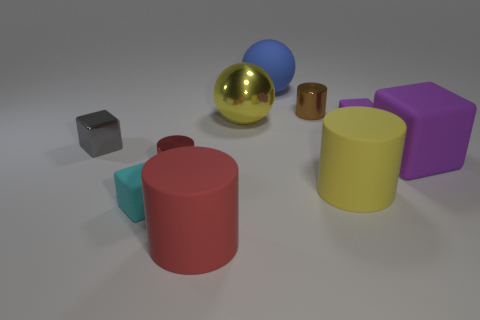Subtract all green cylinders. Subtract all yellow blocks. How many cylinders are left? 4 Subtract all cylinders. How many objects are left? 6 Subtract 0 green cubes. How many objects are left? 10 Subtract all tiny matte objects. Subtract all red cylinders. How many objects are left? 6 Add 9 yellow matte cylinders. How many yellow matte cylinders are left? 10 Add 7 yellow metallic cylinders. How many yellow metallic cylinders exist? 7 